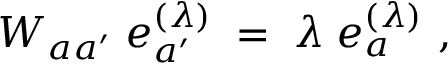Convert formula to latex. <formula><loc_0><loc_0><loc_500><loc_500>W _ { a a ^ { \prime } } \, e _ { a ^ { \prime } } ^ { ( \lambda ) } \, = \, \lambda \, e _ { a } ^ { ( \lambda ) } \ ,</formula> 